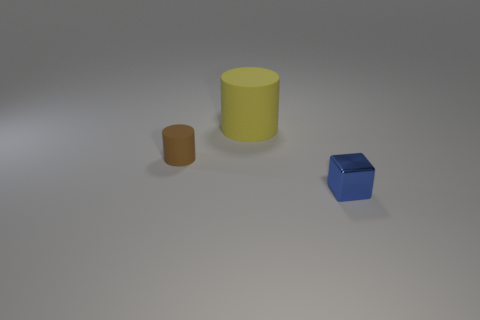If this were a scene from a story, what do you think might happen next? If this were a part of a narrative, one could imagine the objects are characters on a stage. The sequence might unfold with the blue cube 'waking up', realizing it's unique in its environment, and embarking on a quest to discover other cubes or to find a place where it fits perfectly, highlighting themes of self-discovery and belonging. 